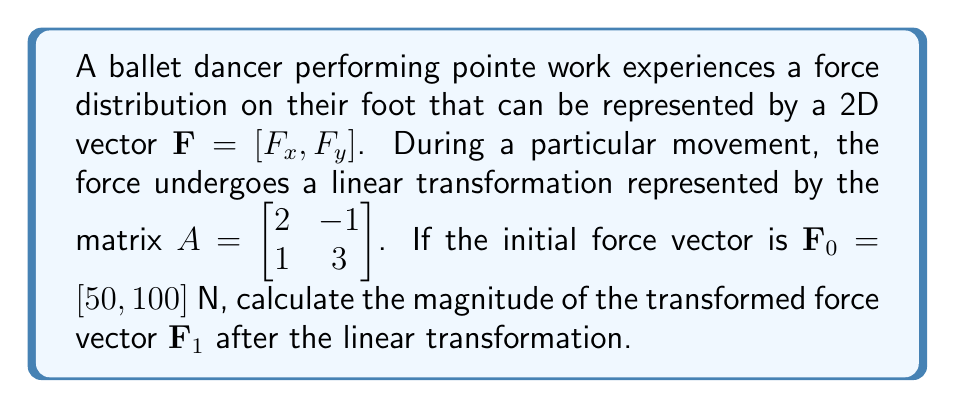Could you help me with this problem? To solve this problem, we'll follow these steps:

1) The linear transformation is given by the equation:
   $\mathbf{F}_1 = A\mathbf{F}_0$

2) Let's perform the matrix multiplication:
   $$\mathbf{F}_1 = \begin{bmatrix} 2 & -1 \\ 1 & 3 \end{bmatrix} \begin{bmatrix} 50 \\ 100 \end{bmatrix}$$

3) Calculating the components:
   $$\mathbf{F}_1 = \begin{bmatrix} (2 \cdot 50) + (-1 \cdot 100) \\ (1 \cdot 50) + (3 \cdot 100) \end{bmatrix} = \begin{bmatrix} 0 \\ 350 \end{bmatrix}$$

4) Now we have the transformed force vector $\mathbf{F}_1 = [0, 350]$ N.

5) To find the magnitude of this vector, we use the Pythagorean theorem:
   $$\|\mathbf{F}_1\| = \sqrt{F_x^2 + F_y^2} = \sqrt{0^2 + 350^2} = \sqrt{122500} = 350 \text{ N}$$

Therefore, the magnitude of the transformed force vector is 350 N.
Answer: 350 N 